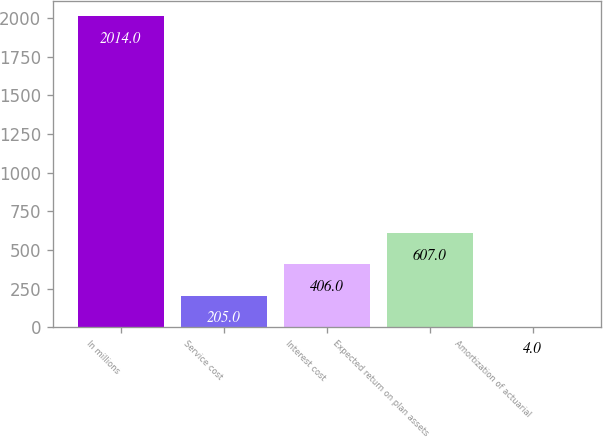Convert chart. <chart><loc_0><loc_0><loc_500><loc_500><bar_chart><fcel>In millions<fcel>Service cost<fcel>Interest cost<fcel>Expected return on plan assets<fcel>Amortization of actuarial<nl><fcel>2014<fcel>205<fcel>406<fcel>607<fcel>4<nl></chart> 